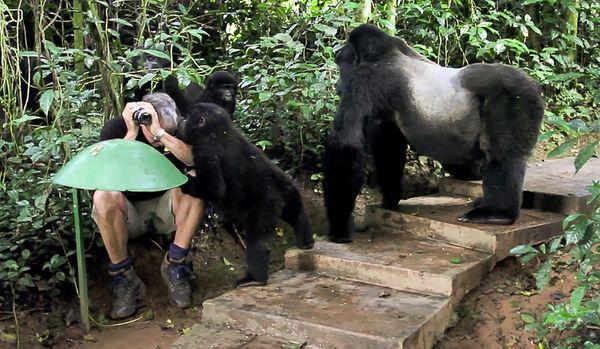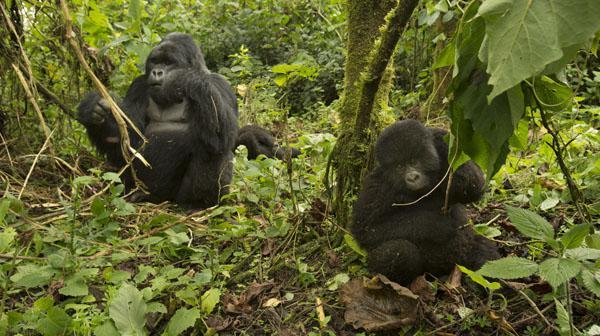The first image is the image on the left, the second image is the image on the right. Given the left and right images, does the statement "There are many gorillas sitting together in the jungle." hold true? Answer yes or no. No. The first image is the image on the left, the second image is the image on the right. For the images displayed, is the sentence "There are no more than seven gorillas." factually correct? Answer yes or no. Yes. 